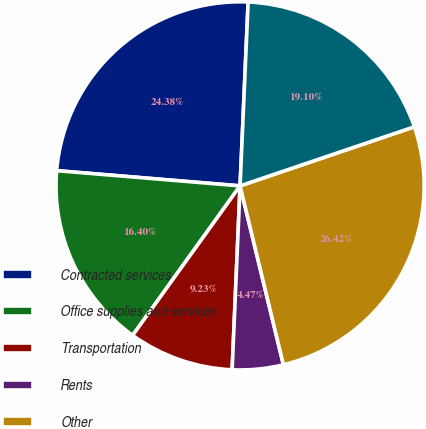<chart> <loc_0><loc_0><loc_500><loc_500><pie_chart><fcel>Contracted services<fcel>Office supplies and services<fcel>Transportation<fcel>Rents<fcel>Other<fcel>Total<nl><fcel>24.38%<fcel>16.4%<fcel>9.23%<fcel>4.47%<fcel>26.42%<fcel>19.1%<nl></chart> 